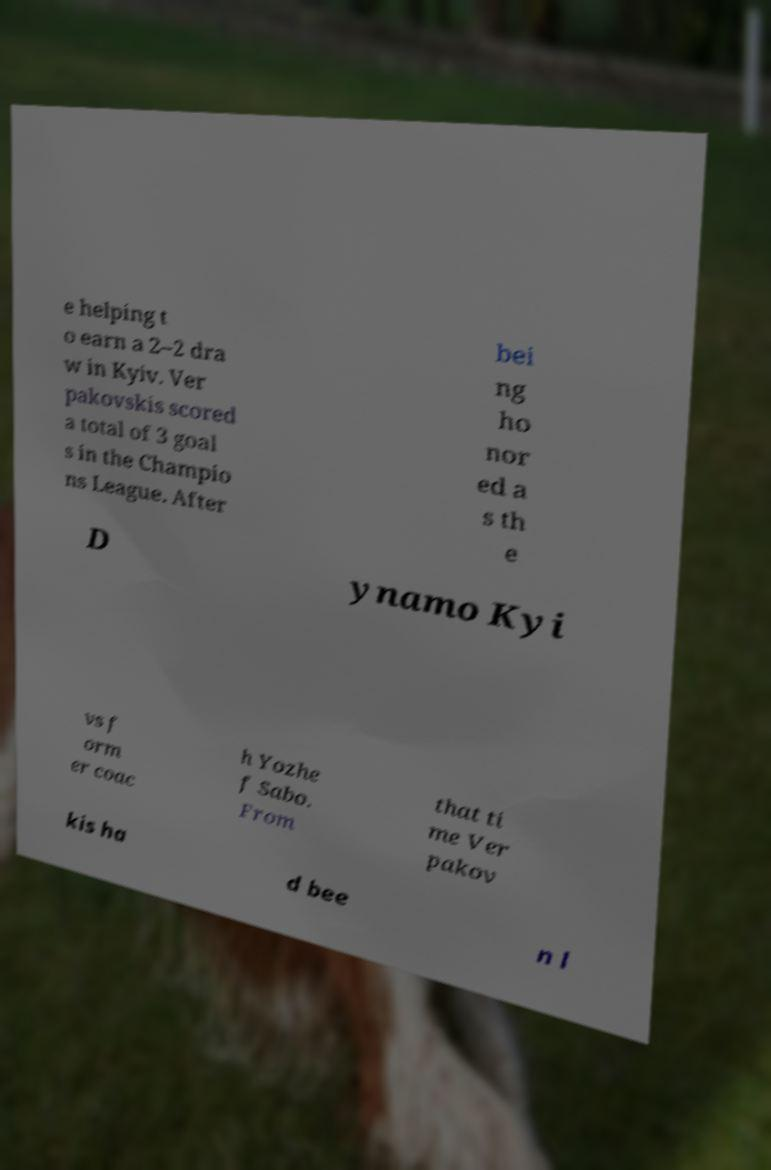Please identify and transcribe the text found in this image. e helping t o earn a 2–2 dra w in Kyiv. Ver pakovskis scored a total of 3 goal s in the Champio ns League. After bei ng ho nor ed a s th e D ynamo Kyi vs f orm er coac h Yozhe f Sabo. From that ti me Ver pakov kis ha d bee n l 